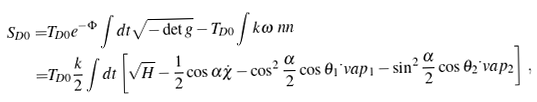<formula> <loc_0><loc_0><loc_500><loc_500>S _ { D 0 } = & T _ { D 0 } e ^ { - \Phi } \int d t \sqrt { - \det g } - T _ { D 0 } \int k \omega \ n n \\ = & T _ { D 0 } \frac { k } { 2 } \int d t \left [ \sqrt { H } - \frac { 1 } { 2 } \cos \alpha \dot { \chi } - \cos ^ { 2 } \frac { \alpha } { 2 } \cos \theta _ { 1 } \dot { \ } v a p _ { 1 } - \sin ^ { 2 } \frac { \alpha } { 2 } \cos \theta _ { 2 } \dot { \ } v a p _ { 2 } \right ] \, ,</formula> 